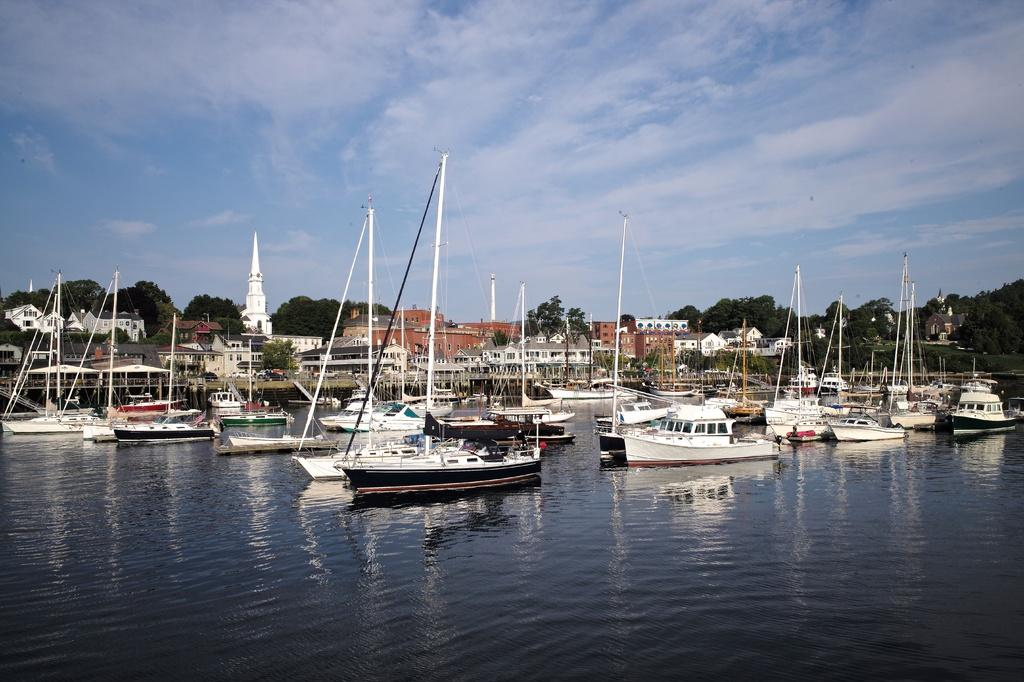What types of watercraft are in the image? There are ships and boats in the image. Where are the ships and boats located? The ships and boats are on the water in the image. What else can be seen in the image besides watercraft? There are buildings, trees, and the sky visible in the image. What is the condition of the sky in the image? The sky is visible in the image, and there are clouds present. How does the stem of the tree help the tree start growing in the image? There is no tree with a stem present in the image; it features ships, boats, buildings, trees, and the sky. 